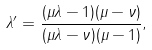<formula> <loc_0><loc_0><loc_500><loc_500>\lambda ^ { \prime } = \frac { ( \mu \lambda - 1 ) ( \mu - \nu ) } { ( \mu \lambda - \nu ) ( \mu - 1 ) } ,</formula> 